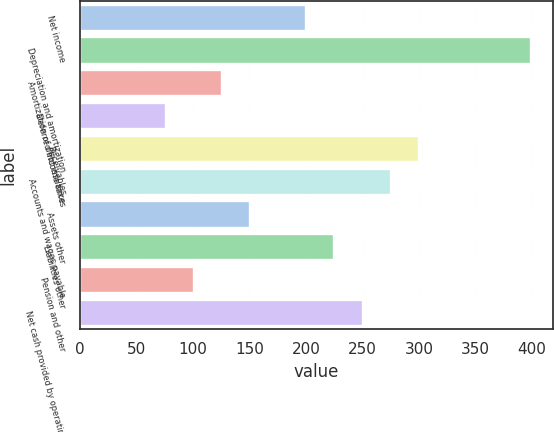Convert chart to OTSL. <chart><loc_0><loc_0><loc_500><loc_500><bar_chart><fcel>Net income<fcel>Depreciation and amortization<fcel>Amortization of debt issuance<fcel>Deferred income taxes<fcel>Receivables<fcel>Accounts and wages payable<fcel>Assets other<fcel>Liabilities other<fcel>Pension and other<fcel>Net cash provided by operating<nl><fcel>200.4<fcel>398.8<fcel>126<fcel>76.4<fcel>299.6<fcel>274.8<fcel>150.8<fcel>225.2<fcel>101.2<fcel>250<nl></chart> 